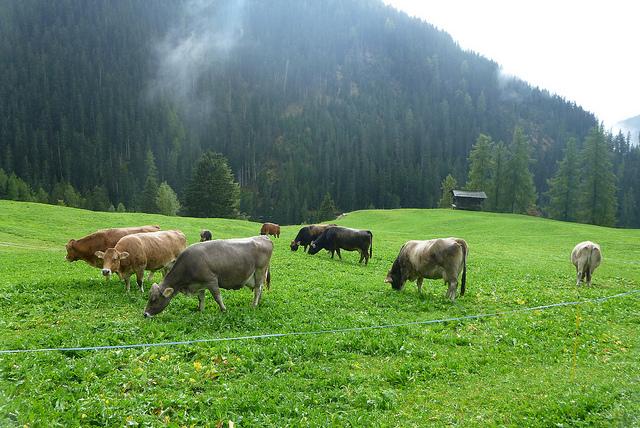Is there a house in the background?
Short answer required. Yes. How many cows in the field?
Answer briefly. 9. Are these animals in their natural environment?
Short answer required. Yes. 